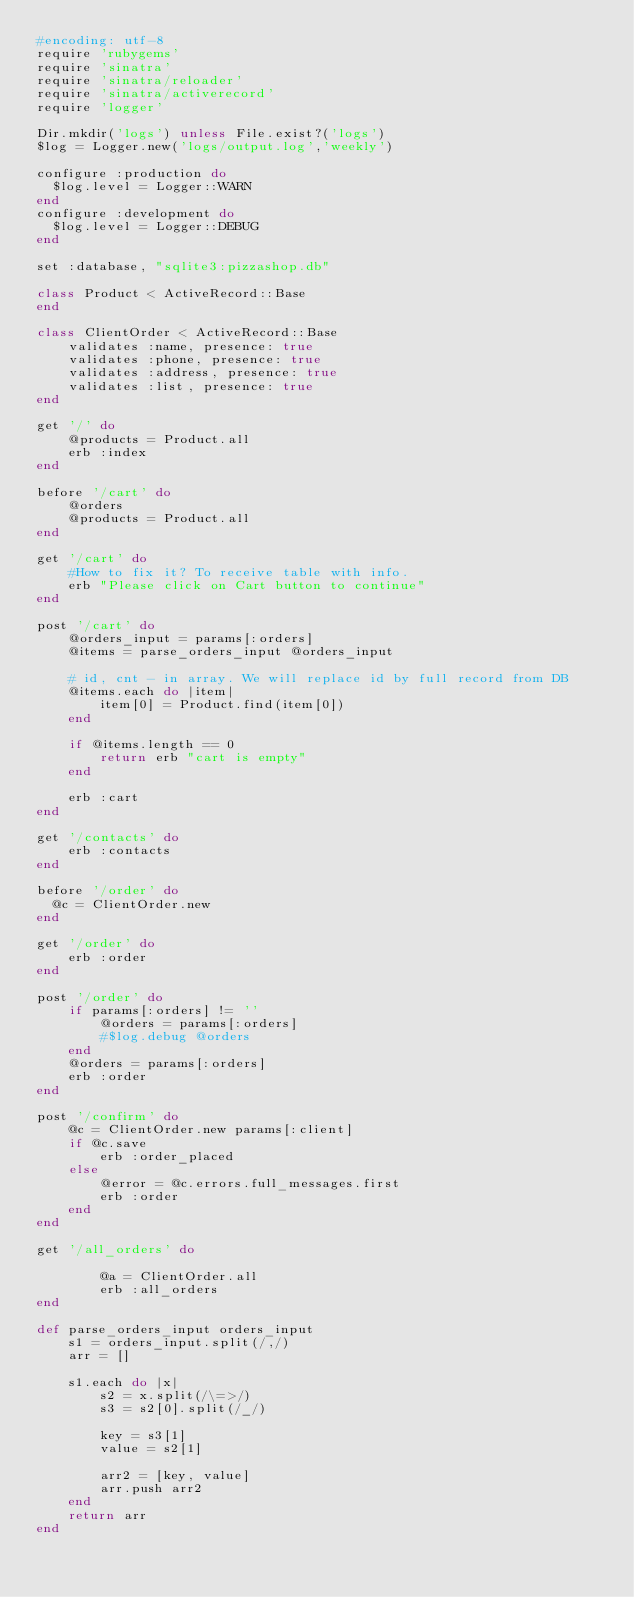Convert code to text. <code><loc_0><loc_0><loc_500><loc_500><_Ruby_>#encoding: utf-8
require 'rubygems'
require 'sinatra'
require 'sinatra/reloader'
require 'sinatra/activerecord'
require 'logger'

Dir.mkdir('logs') unless File.exist?('logs')
$log = Logger.new('logs/output.log','weekly')

configure :production do
  $log.level = Logger::WARN
end
configure :development do
  $log.level = Logger::DEBUG
end

set :database, "sqlite3:pizzashop.db"

class Product < ActiveRecord::Base
end

class ClientOrder < ActiveRecord::Base
	validates :name, presence: true
	validates :phone, presence: true
	validates :address, presence: true
	validates :list, presence: true
end

get '/' do
	@products = Product.all
	erb :index		
end

before '/cart' do
	@orders
	@products = Product.all
end

get '/cart' do
	#How to fix it? To receive table with info.
	erb "Please click on Cart button to continue"
end 

post '/cart' do
	@orders_input = params[:orders]
	@items = parse_orders_input @orders_input

	# id, cnt - in array. We will replace id by full record from DB
	@items.each do |item|
		item[0] = Product.find(item[0])
	end

	if @items.length == 0
		return erb "cart is empty"
	end
		
	erb :cart
end

get '/contacts' do
  	erb :contacts
end

before '/order' do
  @c = ClientOrder.new
end

get '/order' do
  	erb :order
end

post '/order' do
	if params[:orders] != ''
		@orders = params[:orders]
		#$log.debug @orders
	end
	@orders = params[:orders]
  	erb :order
end

post '/confirm' do
	@c = ClientOrder.new params[:client]
	if @c.save
		erb :order_placed
	else
		@error = @c.errors.full_messages.first
		erb :order
	end
end

get '/all_orders' do

		@a = ClientOrder.all
  		erb :all_orders
end

def parse_orders_input orders_input
	s1 = orders_input.split(/,/)
	arr = []

	s1.each do |x|
		s2 = x.split(/\=>/)
		s3 = s2[0].split(/_/)

		key = s3[1]
		value = s2[1]

		arr2 = [key, value]
		arr.push arr2	                                                       
	end
	return arr
end
</code> 